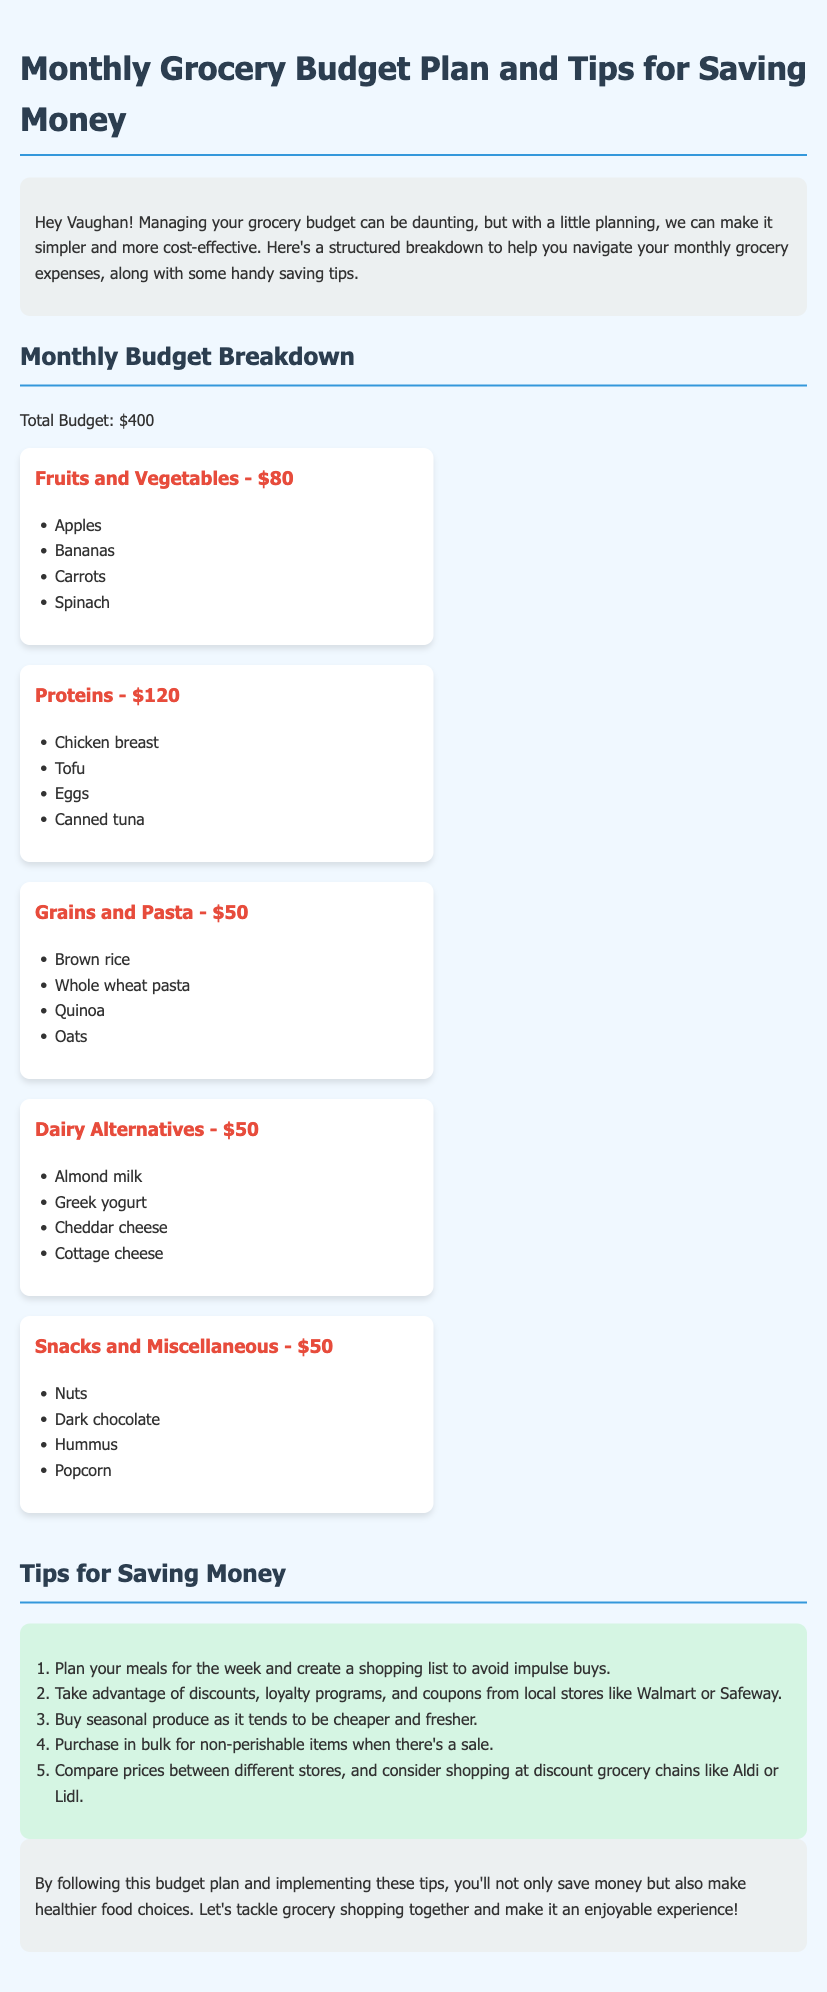What is the total grocery budget? The document states that the total budget for groceries is clearly listed as $400.
Answer: $400 How much is allocated for Proteins? The document provides a specific allocation for the Proteins category, which is $120.
Answer: $120 Which grocery category has the lowest budget? The document lists Grains and Pasta, Dairy Alternatives, and Snacks and Miscellaneous at $50 each, making it the lowest budget category.
Answer: $50 What are two examples of fruits mentioned? The document lists Apples and Bananas as part of the Fruits and Vegetables category.
Answer: Apples, Bananas How many tips for saving money are provided? The document includes a total of five tips for saving money listed in an ordered format.
Answer: 5 Which store chains are mentioned for discounts? The document mentions Walmart and Safeway as stores to consider for discounts, loyalty programs, and coupons.
Answer: Walmart, Safeway What is one of the tips for saving money related to shopping for fresh produce? The document advises buying seasonal produce as it tends to be cheaper and fresher.
Answer: Buy seasonal produce What is the primary purpose of the document? The document aims to help manage monthly grocery expenses and provide tips for saving money effectively.
Answer: Manage grocery expenses Which item is categorized under Snacks and Miscellaneous? The document lists Dark chocolate as one of the items in the Snacks and Miscellaneous category.
Answer: Dark chocolate 